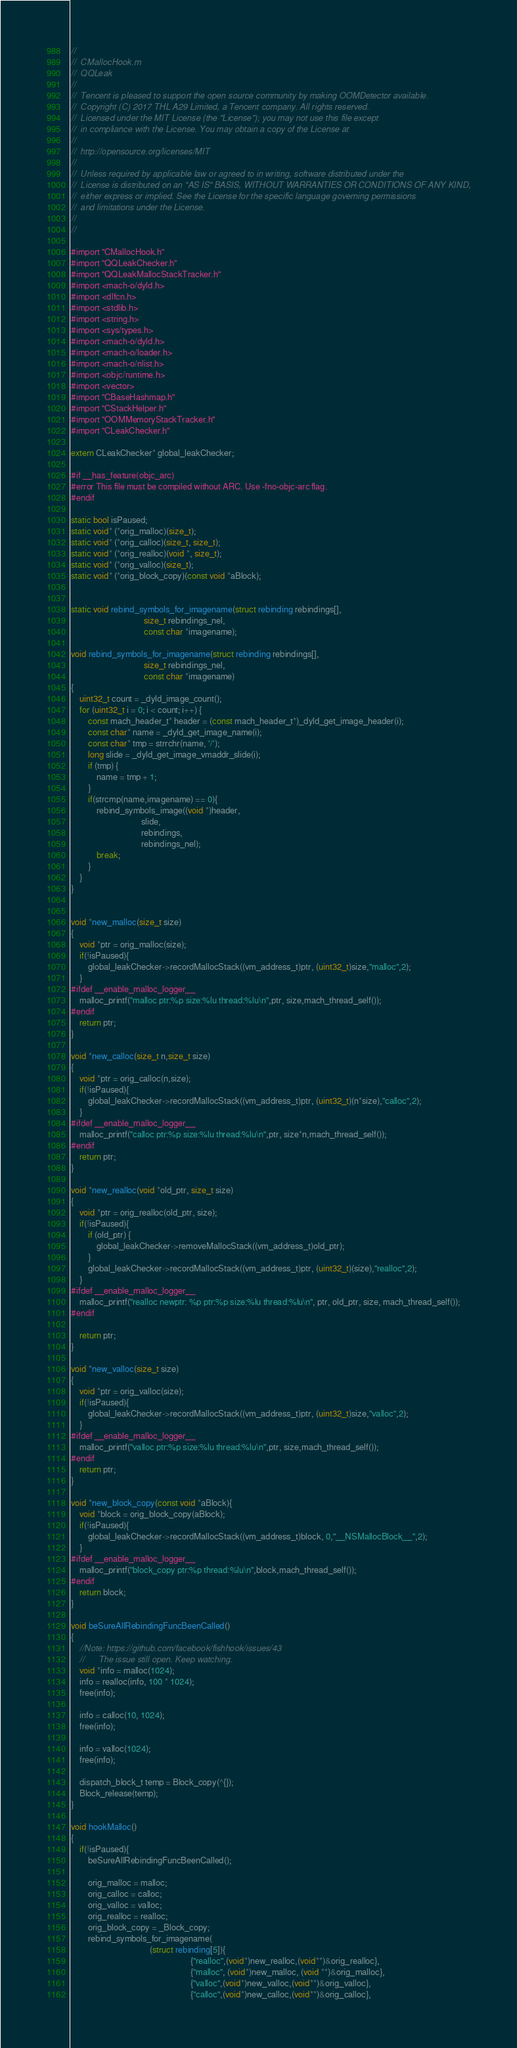<code> <loc_0><loc_0><loc_500><loc_500><_ObjectiveC_>//
//  CMallocHook.m
//  QQLeak
//
//  Tencent is pleased to support the open source community by making OOMDetector available.
//  Copyright (C) 2017 THL A29 Limited, a Tencent company. All rights reserved.
//  Licensed under the MIT License (the "License"); you may not use this file except
//  in compliance with the License. You may obtain a copy of the License at
//
//  http://opensource.org/licenses/MIT
//
//  Unless required by applicable law or agreed to in writing, software distributed under the
//  License is distributed on an "AS IS" BASIS, WITHOUT WARRANTIES OR CONDITIONS OF ANY KIND,
//  either express or implied. See the License for the specific language governing permissions
//  and limitations under the License.
//
//

#import "CMallocHook.h"
#import "QQLeakChecker.h"
#import "QQLeakMallocStackTracker.h"
#import <mach-o/dyld.h>
#import <dlfcn.h>
#import <stdlib.h>
#import <string.h>
#import <sys/types.h>
#import <mach-o/dyld.h>
#import <mach-o/loader.h>
#import <mach-o/nlist.h>
#import <objc/runtime.h>
#import <vector>
#import "CBaseHashmap.h"
#import "CStackHelper.h"
#import "OOMMemoryStackTracker.h"
#import "CLeakChecker.h"

extern CLeakChecker* global_leakChecker;

#if __has_feature(objc_arc)
#error This file must be compiled without ARC. Use -fno-objc-arc flag.
#endif

static bool isPaused;
static void* (*orig_malloc)(size_t);
static void* (*orig_calloc)(size_t, size_t);
static void* (*orig_realloc)(void *, size_t);
static void* (*orig_valloc)(size_t);
static void* (*orig_block_copy)(const void *aBlock);


static void rebind_symbols_for_imagename(struct rebinding rebindings[],
                                  size_t rebindings_nel,
                                  const char *imagename);

void rebind_symbols_for_imagename(struct rebinding rebindings[],
                                  size_t rebindings_nel,
                                  const char *imagename)
{
    uint32_t count = _dyld_image_count();
    for (uint32_t i = 0; i < count; i++) {
        const mach_header_t* header = (const mach_header_t*)_dyld_get_image_header(i);
        const char* name = _dyld_get_image_name(i);
        const char* tmp = strrchr(name, '/');
        long slide = _dyld_get_image_vmaddr_slide(i);
        if (tmp) {
            name = tmp + 1;
        }
        if(strcmp(name,imagename) == 0){
            rebind_symbols_image((void *)header,
                                 slide,
                                 rebindings,
                                 rebindings_nel);
            break;
        }
    }
}


void *new_malloc(size_t size)
{
    void *ptr = orig_malloc(size);
    if(!isPaused){
        global_leakChecker->recordMallocStack((vm_address_t)ptr, (uint32_t)size,"malloc",2);
    }
#ifdef __enable_malloc_logger__
    malloc_printf("malloc ptr:%p size:%lu thread:%lu\n",ptr, size,mach_thread_self());
#endif
    return ptr;
}

void *new_calloc(size_t n,size_t size)
{
    void *ptr = orig_calloc(n,size);
    if(!isPaused){
        global_leakChecker->recordMallocStack((vm_address_t)ptr, (uint32_t)(n*size),"calloc",2);
    }
#ifdef __enable_malloc_logger__
    malloc_printf("calloc ptr:%p size:%lu thread:%lu\n",ptr, size*n,mach_thread_self());
#endif
    return ptr;
}

void *new_realloc(void *old_ptr, size_t size)
{
    void *ptr = orig_realloc(old_ptr, size);
    if(!isPaused){
        if (old_ptr) {
            global_leakChecker->removeMallocStack((vm_address_t)old_ptr);
        }
        global_leakChecker->recordMallocStack((vm_address_t)ptr, (uint32_t)(size),"realloc",2);
    }
#ifdef __enable_malloc_logger__
    malloc_printf("realloc newptr: %p ptr:%p size:%lu thread:%lu\n", ptr, old_ptr, size, mach_thread_self());
#endif
    
    return ptr;
}

void *new_valloc(size_t size)
{
    void *ptr = orig_valloc(size);
    if(!isPaused){
        global_leakChecker->recordMallocStack((vm_address_t)ptr, (uint32_t)size,"valloc",2);
    }
#ifdef __enable_malloc_logger__
    malloc_printf("valloc ptr:%p size:%lu thread:%lu\n",ptr, size,mach_thread_self());
#endif
    return ptr;
}

void *new_block_copy(const void *aBlock){
    void *block = orig_block_copy(aBlock);
    if(!isPaused){
        global_leakChecker->recordMallocStack((vm_address_t)block, 0,"__NSMallocBlock__",2);
    }
#ifdef __enable_malloc_logger__
    malloc_printf("block_copy ptr:%p thread:%lu\n",block,mach_thread_self());
#endif
    return block;
}

void beSureAllRebindingFuncBeenCalled()
{
    //Note: https://github.com/facebook/fishhook/issues/43
    //      The issue still open. Keep watching.
    void *info = malloc(1024);
    info = realloc(info, 100 * 1024);
    free(info);
    
    info = calloc(10, 1024);
    free(info);
    
    info = valloc(1024);
    free(info);
    
    dispatch_block_t temp = Block_copy(^{});
    Block_release(temp);
}

void hookMalloc()
{
    if(!isPaused){
        beSureAllRebindingFuncBeenCalled();
        
        orig_malloc = malloc;
        orig_calloc = calloc;
        orig_valloc = valloc;
        orig_realloc = realloc;
        orig_block_copy = _Block_copy;
        rebind_symbols_for_imagename(
                                     (struct rebinding[5]){
                                                        {"realloc",(void*)new_realloc,(void**)&orig_realloc},
                                                        {"malloc", (void*)new_malloc, (void **)&orig_malloc},
                                                        {"valloc",(void*)new_valloc,(void**)&orig_valloc},
                                                        {"calloc",(void*)new_calloc,(void**)&orig_calloc},</code> 